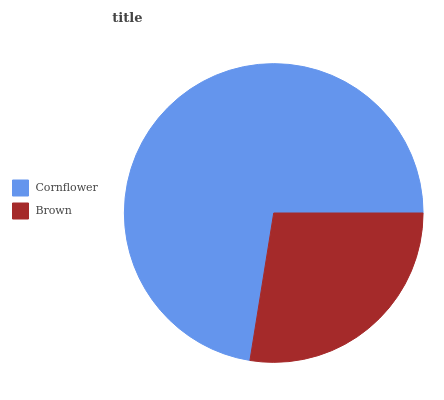Is Brown the minimum?
Answer yes or no. Yes. Is Cornflower the maximum?
Answer yes or no. Yes. Is Brown the maximum?
Answer yes or no. No. Is Cornflower greater than Brown?
Answer yes or no. Yes. Is Brown less than Cornflower?
Answer yes or no. Yes. Is Brown greater than Cornflower?
Answer yes or no. No. Is Cornflower less than Brown?
Answer yes or no. No. Is Cornflower the high median?
Answer yes or no. Yes. Is Brown the low median?
Answer yes or no. Yes. Is Brown the high median?
Answer yes or no. No. Is Cornflower the low median?
Answer yes or no. No. 